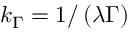Convert formula to latex. <formula><loc_0><loc_0><loc_500><loc_500>k _ { \Gamma } = 1 / \left ( \lambda \Gamma \right )</formula> 